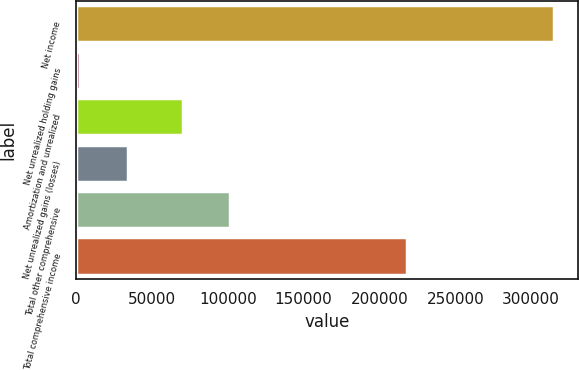Convert chart. <chart><loc_0><loc_0><loc_500><loc_500><bar_chart><fcel>Net income<fcel>Net unrealized holding gains<fcel>Amortization and unrealized<fcel>Net unrealized gains (losses)<fcel>Total other comprehensive<fcel>Total comprehensive income<nl><fcel>315075<fcel>2713<fcel>70461<fcel>33949.2<fcel>101697<fcel>218138<nl></chart> 